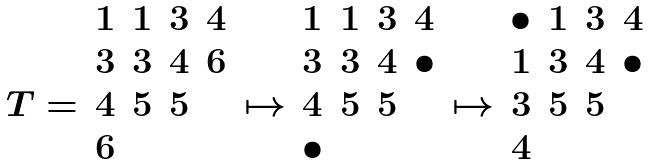<formula> <loc_0><loc_0><loc_500><loc_500>\begin{array} { c c c c c c c c c c c c c c c } & 1 & 1 & 3 & 4 & & 1 & 1 & 3 & 4 & & \bullet & 1 & 3 & 4 \\ & 3 & 3 & 4 & 6 & & 3 & 3 & 4 & \bullet & & 1 & 3 & 4 & \bullet \\ T = & 4 & 5 & 5 & & \mapsto & 4 & 5 & 5 & & \mapsto & 3 & 5 & 5 & \\ & 6 & & & & & \bullet & & & & & 4 & & & \end{array}</formula> 